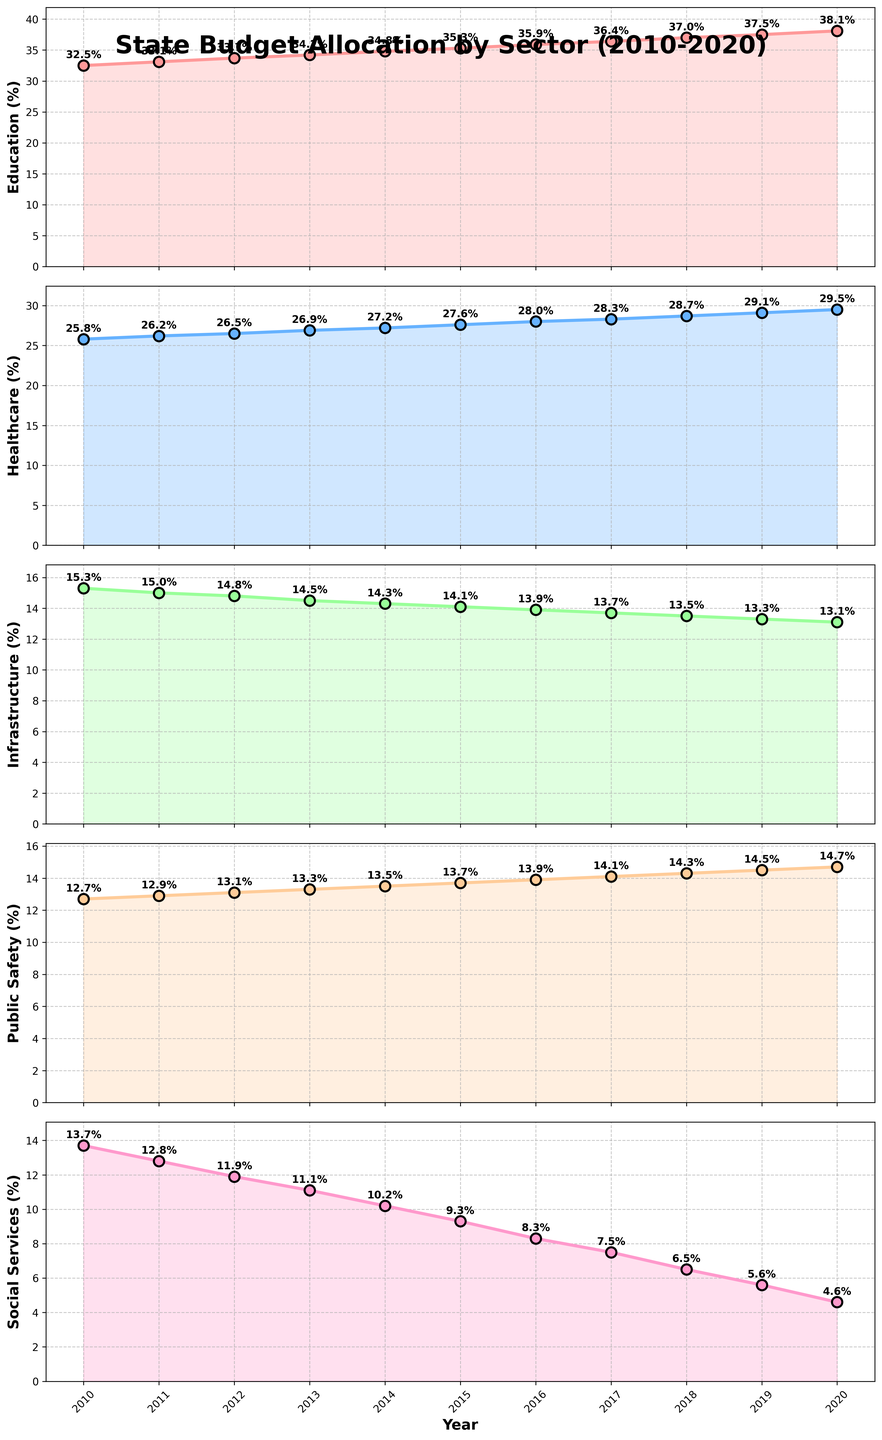What trend is observed in the allocation for Education from 2010 to 2020? To identify the trend, look at the plot for Education (the topmost plot). Notice that the percentage allocated to Education rises each year, starting from 32.5% in 2010 and reaching 38.1% in 2020. This indicates a steady increase in funding.
Answer: Steadily increasing In which year did Healthcare allocation first reach or exceed 29%? Check the plot for Healthcare (the second plot). Locate when the line first hits or exceeds the 29% mark. This occurs in 2019 when the allocation is 29.1%.
Answer: 2019 Comparing 2010 and 2020, how much did the allocation to Social Services decrease? Locate the points for Social Services (the bottommost plot) in 2010 (13.7%) and 2020 (4.6%). Calculate the difference: 13.7% - 4.6% = 9.1%.
Answer: 9.1% Which sector experienced the most consistent increase in funding percentage over the 10-year period? Compare the plots of all sectors. Education (topmost plot) shows a consistent year-by-year increase from 32.5% to 38.1%, unlike other sectors which have more fluctuations.
Answer: Education How does the funding trend for Public Safety differ from that of Social Services from 2010 to 2020? Observe the Public Safety plot (the fourth plot) and Social Services plot (the fifth plot). Public Safety shows a gradual increase from 12.7% to 14.7%, while Social Services show a continual decrease from 13.7% to 4.6%.
Answer: Public Safety increases, Social Services decreases By how much does the peak allocation of Infrastructure in 2010 differ from its lowest allocation in 2020? Refer to the Infrastructure plot (the third plot). The highest allocation in 2010 is 15.3%, and the lowest is 13.1% in 2020. Calculate the difference: 15.3% - 13.1% = 2.2%.
Answer: 2.2% What is the total percentage allocation for Education and Healthcare combined in 2020? Sum the allocations in 2020 for both Education (38.1%) and Healthcare (29.5%). 38.1% + 29.5% = 67.6%.
Answer: 67.6% In the year 2015, how much higher was the allocation for Education compared to Social Services? Find the allocations for both Education (35.3%) and Social Services (9.3%) in 2015. Subtract the Social Services allocation from the Education allocation: 35.3% - 9.3% = 26.0%.
Answer: 26.0% Which sector has the smallest absolute change in percentage allocation from 2010 to 2020? To determine this, calculate the absolute change for each sector: 
- Education: 38.1% - 32.5% = 5.6%
- Healthcare: 29.5% - 25.8% = 3.7%
- Infrastructure: 13.1% - 15.3% = 2.2%
- Public Safety: 14.7% - 12.7% = 2.0%
- Social Services: 4.6% - 13.7% = 9.1%
The smallest change is for Public Safety: 2.0%.
Answer: Public Safety 